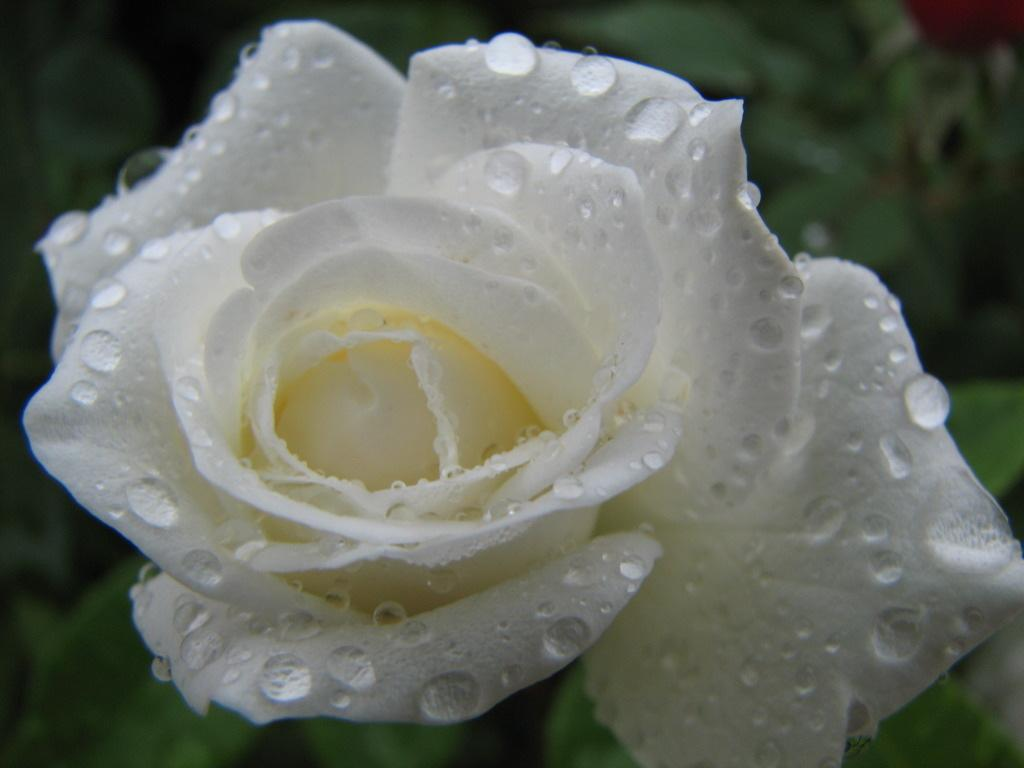What is the main subject of the picture? The main subject of the picture is a flower. Can you describe the appearance of the flower? The flower has water drops on it. What historical event is depicted in the picture involving cats? There is no historical event or cats depicted in the picture; it features a flower with water drops on it. 